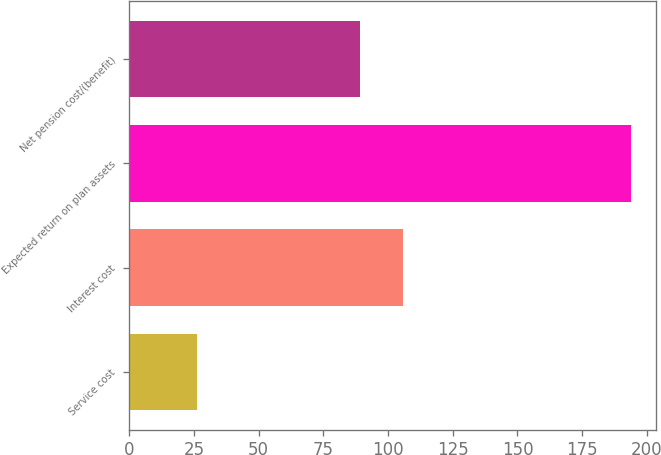Convert chart. <chart><loc_0><loc_0><loc_500><loc_500><bar_chart><fcel>Service cost<fcel>Interest cost<fcel>Expected return on plan assets<fcel>Net pension cost/(benefit)<nl><fcel>26<fcel>105.8<fcel>194<fcel>89<nl></chart> 